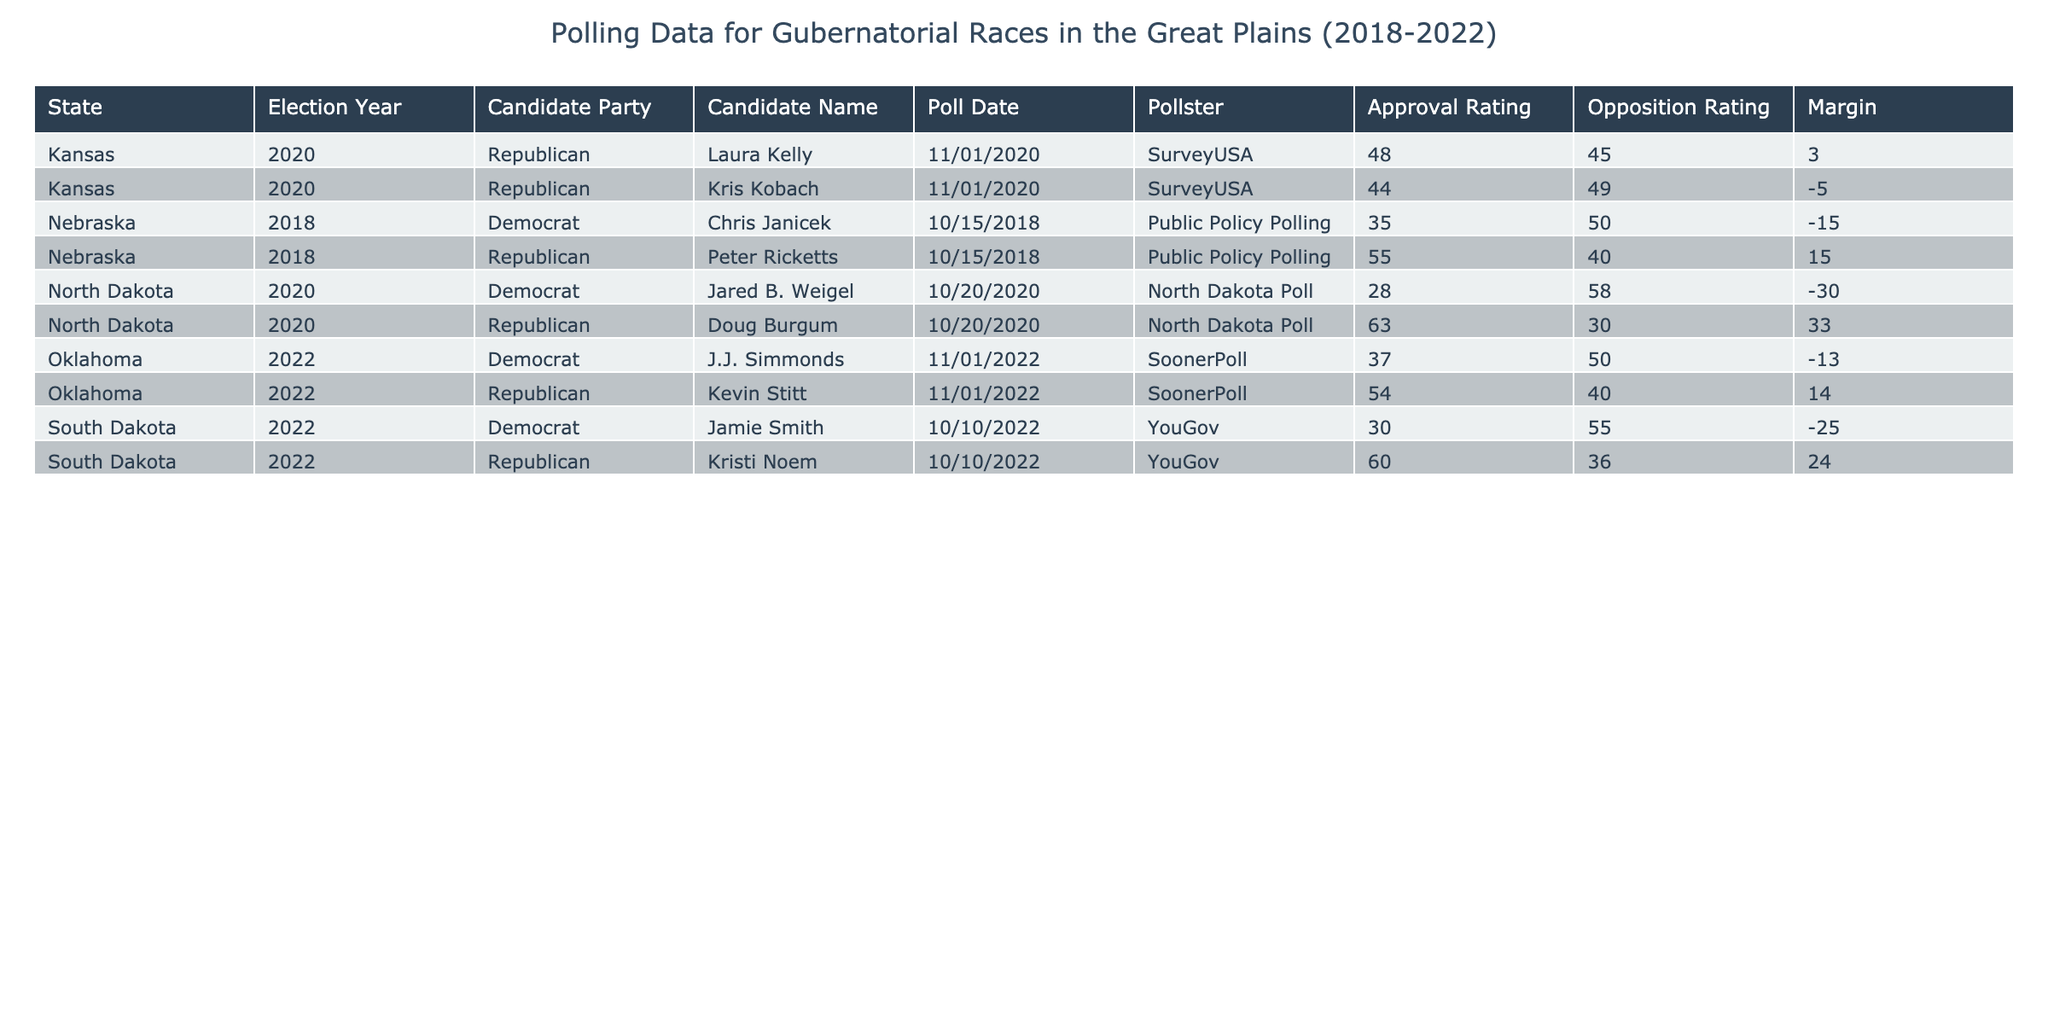What is the approval rating for Peter Ricketts in Nebraska in 2018? The approval rating for Peter Ricketts, who was a Republican candidate in Nebraska in 2018, is listed in the table under the Approval Rating column for that specific entry. The table shows an approval rating of 55.
Answer: 55 What is the opposition rating for Jamie Smith in South Dakota in 2022? The opposition rating for Jamie Smith, the Democrat candidate in South Dakota in 2022, can be found in the table under the Opposition Rating column for that row. The value is 55.
Answer: 55 Which candidate had the highest margin of victory and what was the margin? To find the candidate with the highest margin of victory, we must look at the Margin column across all entries and identify the maximum value. The maximum margin is 33, which belongs to Doug Burgum from North Dakota in 2020.
Answer: 33 What is the average opposition rating for Democratic candidates across the years? The opposition ratings for Democratic candidates are 50 (Chris Janicek), 58 (Jared B. Weigel), 55 (Jamie Smith), and 50 (J.J. Simmonds). To find the average, sum these values (50 + 58 + 55 + 50 = 213) and divide by the number of Democratic candidates (4). The average is 213 / 4 = 53.25.
Answer: 53.25 Did Kristi Noem have a higher approval rating than the opposition rating in 2022? We can compare the two values in the table for Kristi Noem in 2022. Her approval rating is 60 and her opposition rating is 36. Since 60 is greater than 36, the answer is yes.
Answer: Yes How do the approval ratings for Republican candidates compare between 2018 in Nebraska and 2022 in South Dakota? The approval rating for Peter Ricketts, the Republican candidate in Nebraska in 2018, is 55. In South Dakota in 2022, the Republican candidate Kristi Noem has an approval rating of 60. Comparing these two values, 60 (South Dakota) is greater than 55 (Nebraska).
Answer: Kristi Noem's approval rating is higher Was there a Democratic candidate in Kansas in the 2020 election? By checking the table for Kansas in 2020, we see a Democratic candidate named Jared B. Weigel listed. Therefore, the statement is true.
Answer: Yes What is the difference in approval ratings between Doug Burgum in North Dakota and Chris Janicek in Nebraska? We will subtract the approval rating of Chris Janicek from that of Doug Burgum. Doug Burgum's approval rating is 63 and Chris Janicek's is 35. The difference is 63 - 35 = 28.
Answer: 28 What was the number of Democratic candidates and their average margin of defeat? The Democratic candidates in the table are Chris Janicek (-15), Jared B. Weigel (-30), Jamie Smith (-25), and J.J. Simmonds (-13), making a total of 4 candidates. To calculate their average margin of defeat, sum (-15 - 30 - 25 - 13 = -83) and divide by 4, giving -83 / 4 = -20.75.
Answer: -20.75 